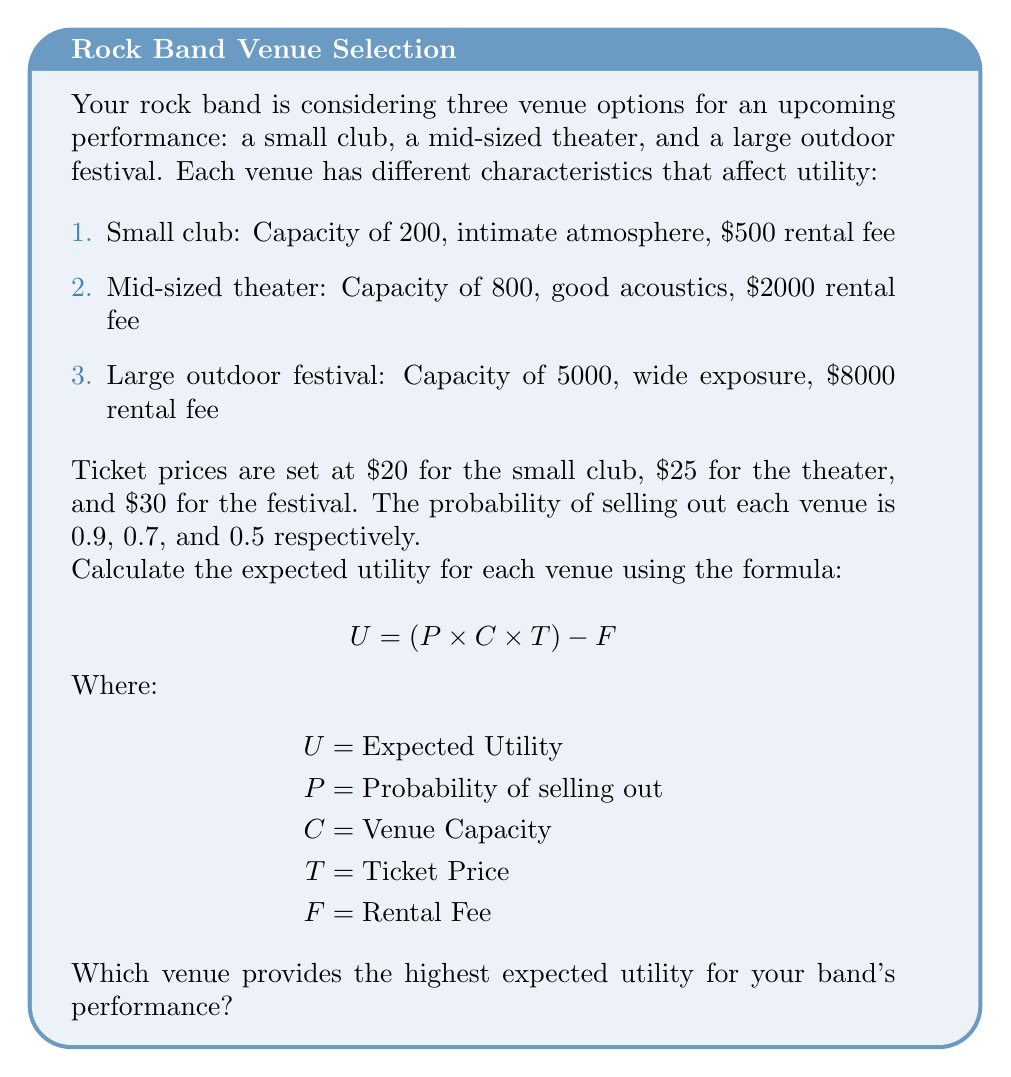Can you solve this math problem? Let's calculate the expected utility for each venue:

1. Small club:
$$ U_1 = (0.9 \times 200 \times $20) - $500 $$
$$ U_1 = $3600 - $500 = $3100 $$

2. Mid-sized theater:
$$ U_2 = (0.7 \times 800 \times $25) - $2000 $$
$$ U_2 = $14000 - $2000 = $12000 $$

3. Large outdoor festival:
$$ U_3 = (0.5 \times 5000 \times $30) - $8000 $$
$$ U_3 = $75000 - $8000 = $67000 $$

Comparing the expected utilities:
$U_1 = $3100$
$U_2 = $12000$
$U_3 = $67000$

The large outdoor festival provides the highest expected utility.
Answer: Large outdoor festival ($67000) 